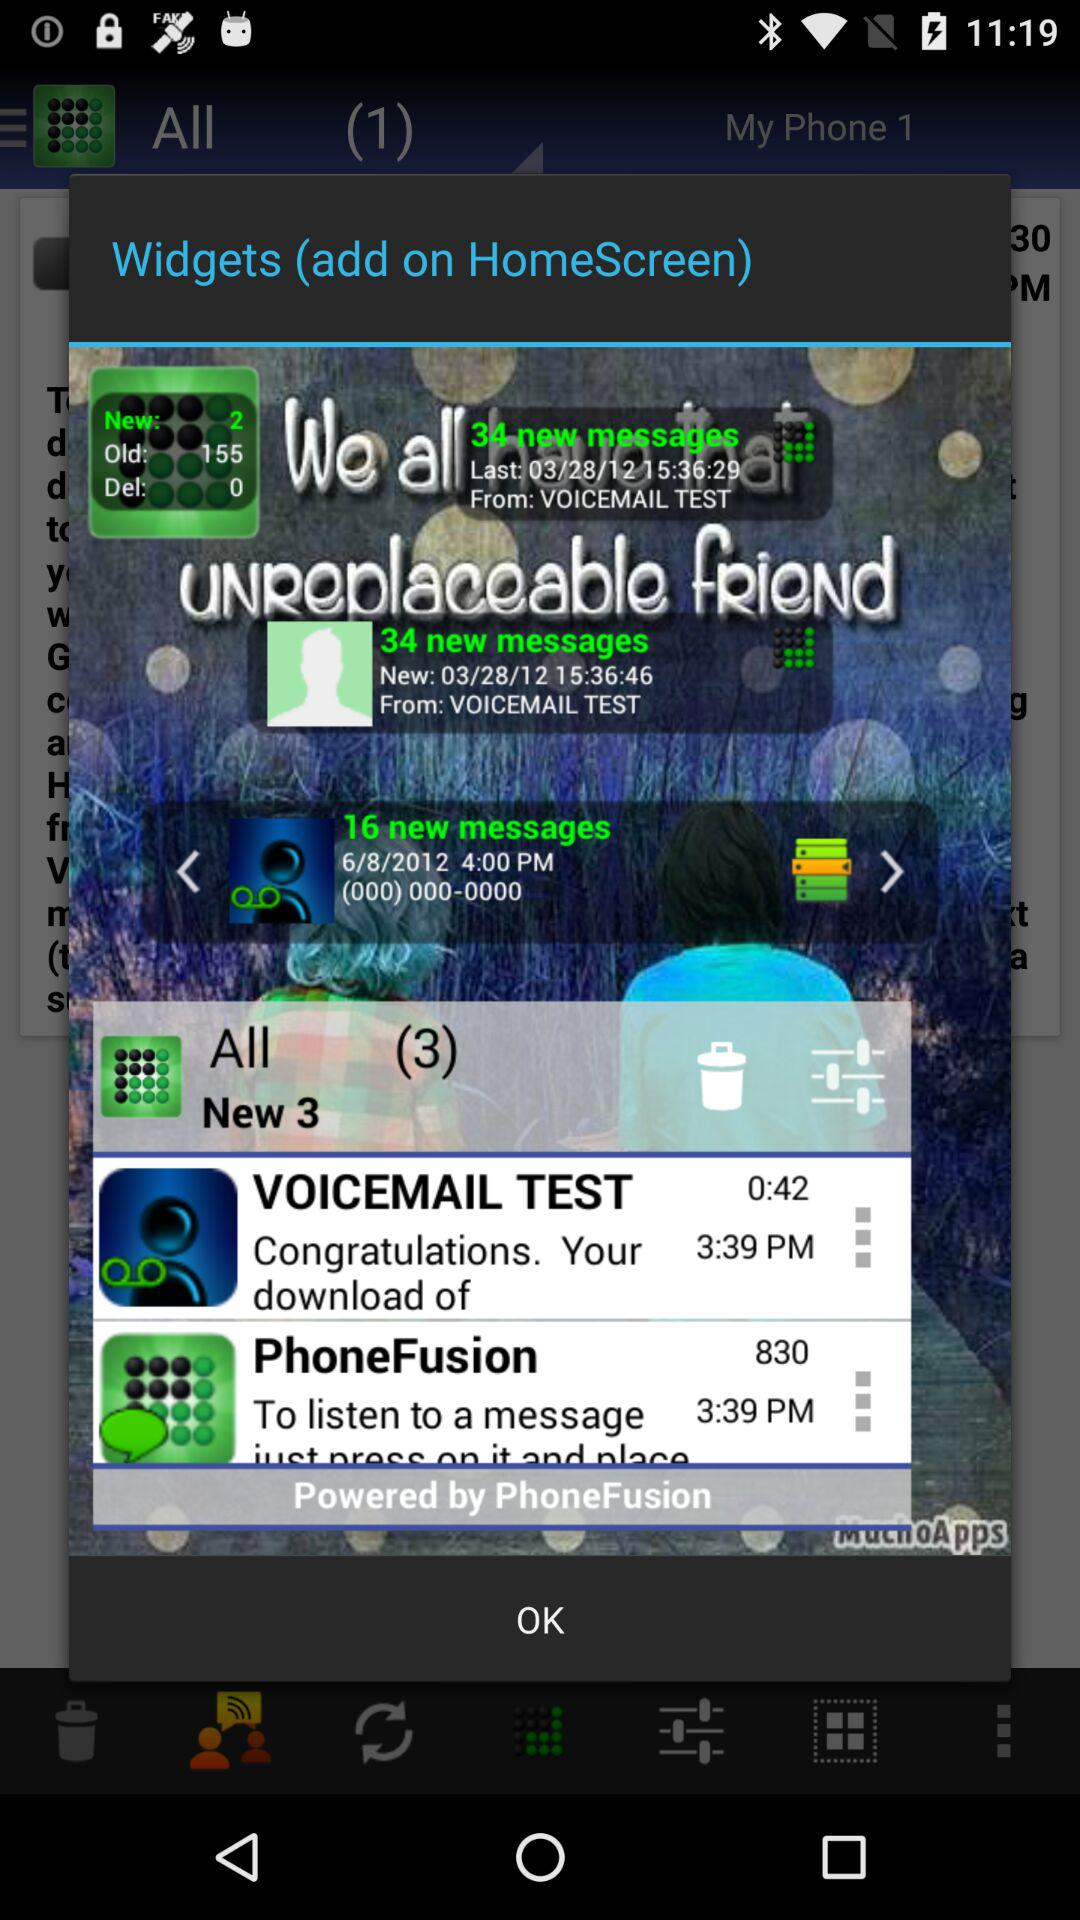How many messages are there from the Voicemail Test?
When the provided information is insufficient, respond with <no answer>. <no answer> 